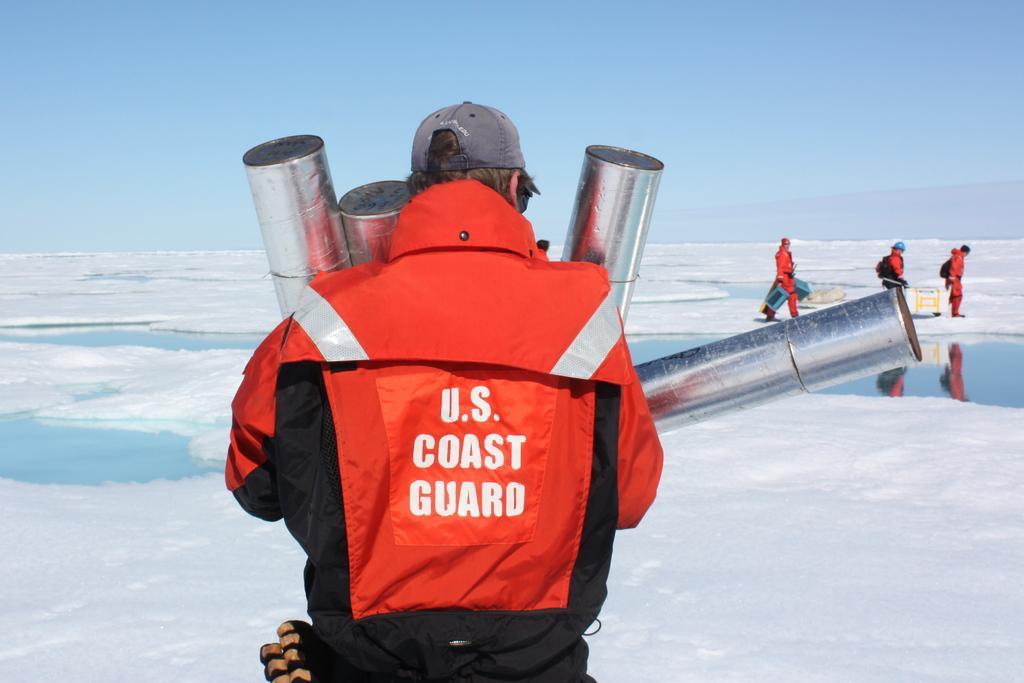Could you give a brief overview of what you see in this image? In this image we can see a group of people standing on the snow. One person is holding metal rods in his hands. One person is wearing a helmet and carrying a bag. In the background, we can see a board, water and the sky. 